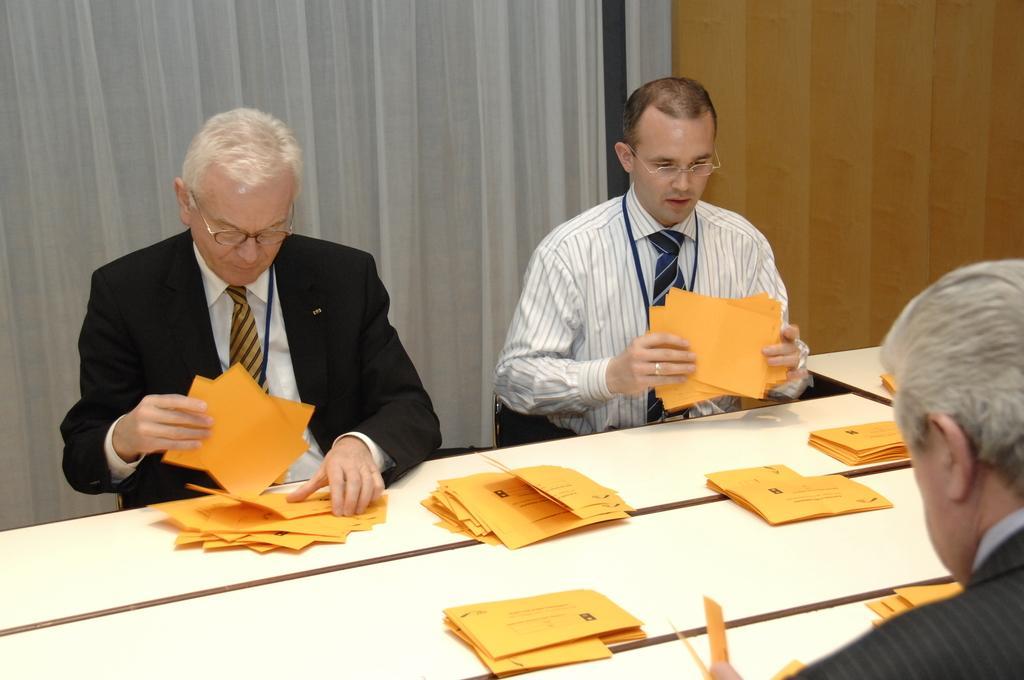Could you give a brief overview of what you see in this image? In this image I see 3 men who are sitting on chairs and I see that all of them are holding orange color things in their hands and I see few more orange color papers on this table. In the background I see the curtains. 